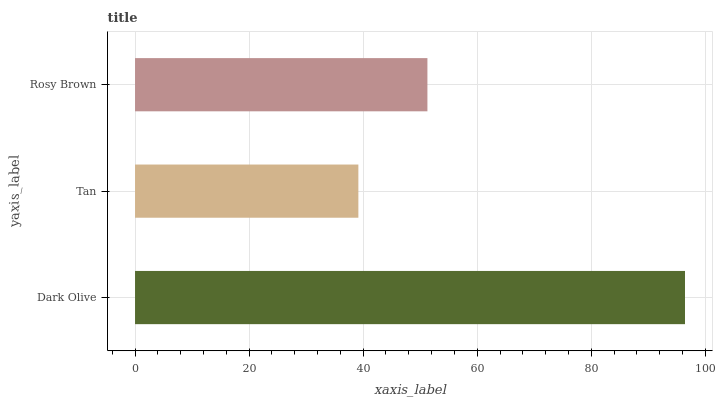Is Tan the minimum?
Answer yes or no. Yes. Is Dark Olive the maximum?
Answer yes or no. Yes. Is Rosy Brown the minimum?
Answer yes or no. No. Is Rosy Brown the maximum?
Answer yes or no. No. Is Rosy Brown greater than Tan?
Answer yes or no. Yes. Is Tan less than Rosy Brown?
Answer yes or no. Yes. Is Tan greater than Rosy Brown?
Answer yes or no. No. Is Rosy Brown less than Tan?
Answer yes or no. No. Is Rosy Brown the high median?
Answer yes or no. Yes. Is Rosy Brown the low median?
Answer yes or no. Yes. Is Dark Olive the high median?
Answer yes or no. No. Is Dark Olive the low median?
Answer yes or no. No. 